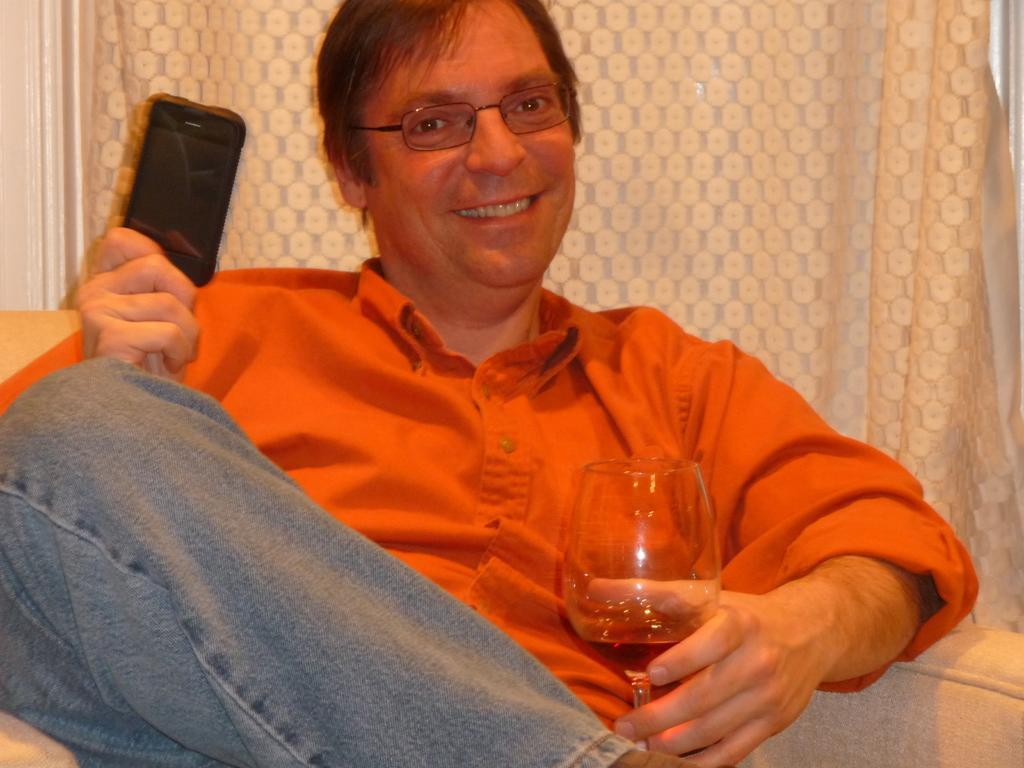In one or two sentences, can you explain what this image depicts? In this picture there is a man sitting on a chair and holding a glass. He is also holding a phone in his hand. There is a cream curtain in the background. 